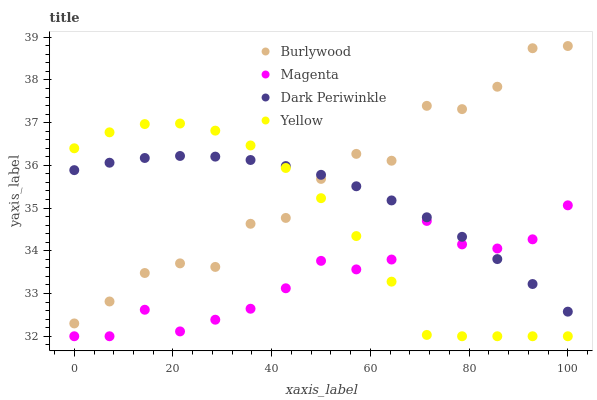Does Magenta have the minimum area under the curve?
Answer yes or no. Yes. Does Burlywood have the maximum area under the curve?
Answer yes or no. Yes. Does Dark Periwinkle have the minimum area under the curve?
Answer yes or no. No. Does Dark Periwinkle have the maximum area under the curve?
Answer yes or no. No. Is Dark Periwinkle the smoothest?
Answer yes or no. Yes. Is Burlywood the roughest?
Answer yes or no. Yes. Is Magenta the smoothest?
Answer yes or no. No. Is Magenta the roughest?
Answer yes or no. No. Does Magenta have the lowest value?
Answer yes or no. Yes. Does Dark Periwinkle have the lowest value?
Answer yes or no. No. Does Burlywood have the highest value?
Answer yes or no. Yes. Does Dark Periwinkle have the highest value?
Answer yes or no. No. Is Magenta less than Burlywood?
Answer yes or no. Yes. Is Burlywood greater than Magenta?
Answer yes or no. Yes. Does Dark Periwinkle intersect Yellow?
Answer yes or no. Yes. Is Dark Periwinkle less than Yellow?
Answer yes or no. No. Is Dark Periwinkle greater than Yellow?
Answer yes or no. No. Does Magenta intersect Burlywood?
Answer yes or no. No. 